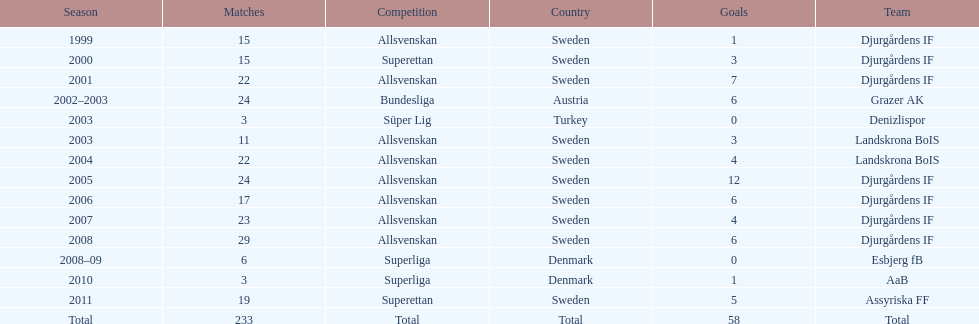What is the overall count of matches that took place? 233. Parse the table in full. {'header': ['Season', 'Matches', 'Competition', 'Country', 'Goals', 'Team'], 'rows': [['1999', '15', 'Allsvenskan', 'Sweden', '1', 'Djurgårdens IF'], ['2000', '15', 'Superettan', 'Sweden', '3', 'Djurgårdens IF'], ['2001', '22', 'Allsvenskan', 'Sweden', '7', 'Djurgårdens IF'], ['2002–2003', '24', 'Bundesliga', 'Austria', '6', 'Grazer AK'], ['2003', '3', 'Süper Lig', 'Turkey', '0', 'Denizlispor'], ['2003', '11', 'Allsvenskan', 'Sweden', '3', 'Landskrona BoIS'], ['2004', '22', 'Allsvenskan', 'Sweden', '4', 'Landskrona BoIS'], ['2005', '24', 'Allsvenskan', 'Sweden', '12', 'Djurgårdens IF'], ['2006', '17', 'Allsvenskan', 'Sweden', '6', 'Djurgårdens IF'], ['2007', '23', 'Allsvenskan', 'Sweden', '4', 'Djurgårdens IF'], ['2008', '29', 'Allsvenskan', 'Sweden', '6', 'Djurgårdens IF'], ['2008–09', '6', 'Superliga', 'Denmark', '0', 'Esbjerg fB'], ['2010', '3', 'Superliga', 'Denmark', '1', 'AaB'], ['2011', '19', 'Superettan', 'Sweden', '5', 'Assyriska FF'], ['Total', '233', 'Total', 'Total', '58', 'Total']]} 